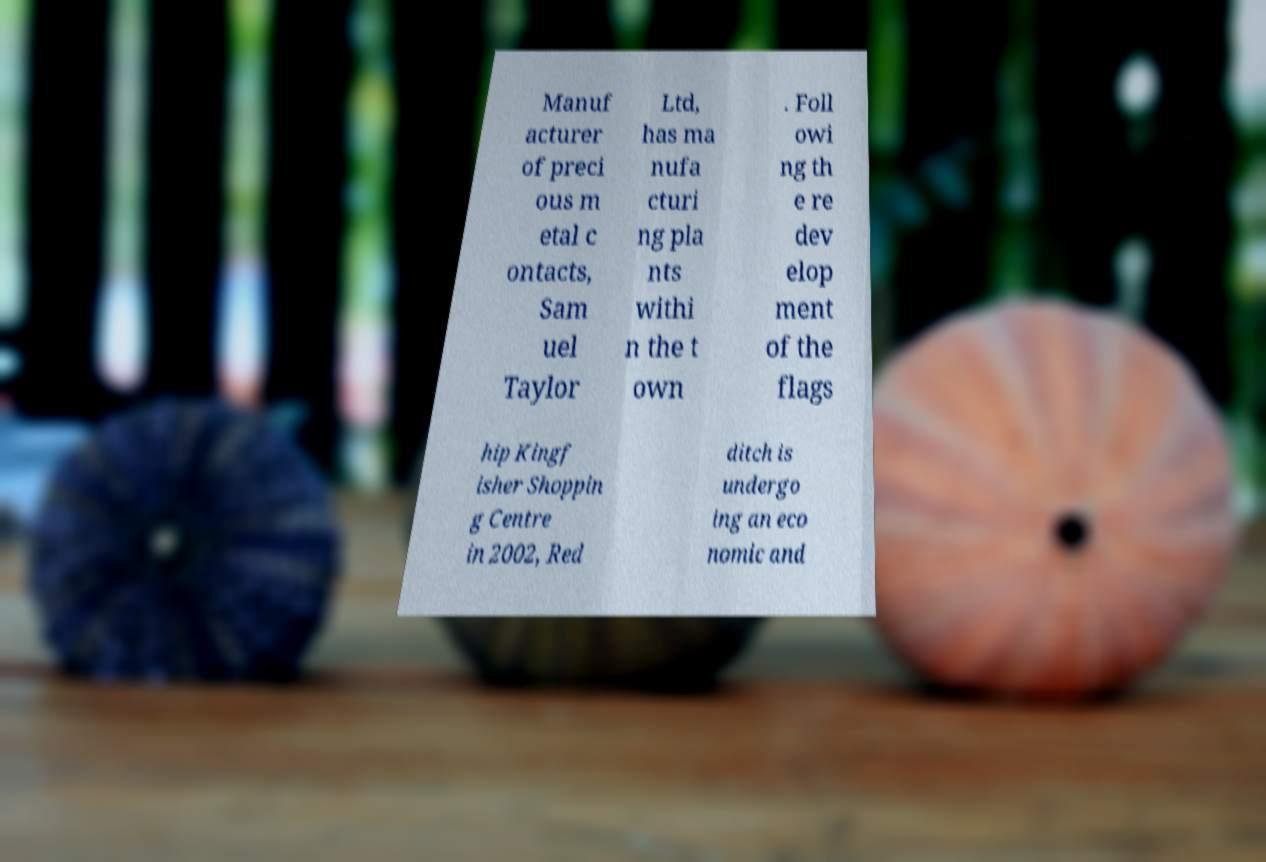I need the written content from this picture converted into text. Can you do that? Manuf acturer of preci ous m etal c ontacts, Sam uel Taylor Ltd, has ma nufa cturi ng pla nts withi n the t own . Foll owi ng th e re dev elop ment of the flags hip Kingf isher Shoppin g Centre in 2002, Red ditch is undergo ing an eco nomic and 